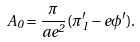<formula> <loc_0><loc_0><loc_500><loc_500>A _ { 0 } = { \frac { \pi } { a e ^ { 2 } } } ( \pi _ { 1 } ^ { \prime } - e \phi ^ { \prime } ) .</formula> 